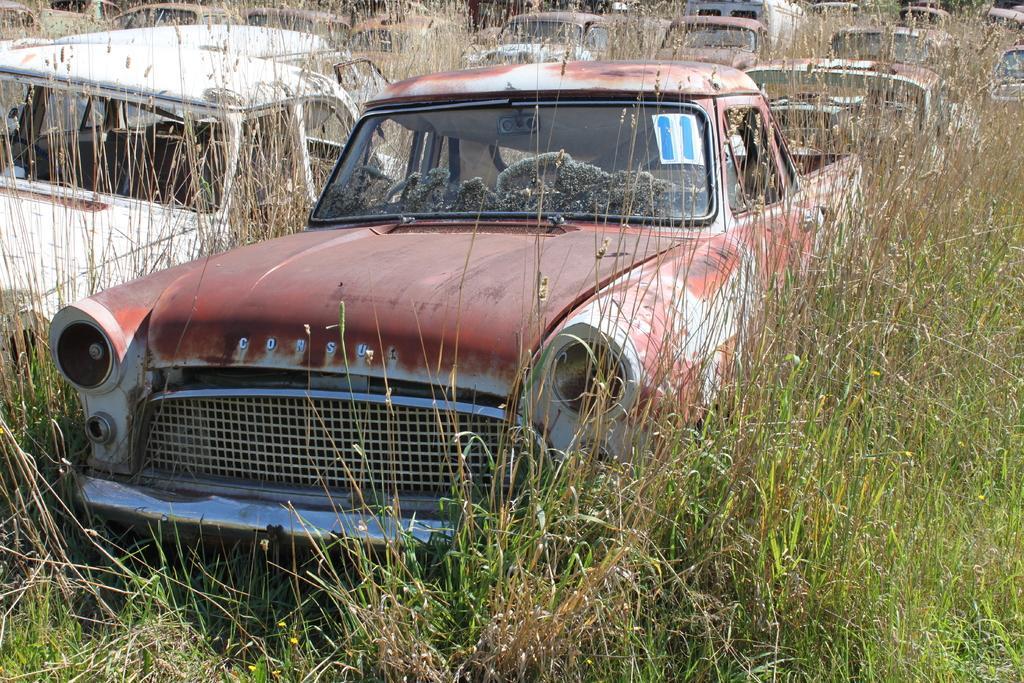Please provide a concise description of this image. In this image there are a group of vehicles, there is grass, there is a paper on the car, there is number on the paper. 